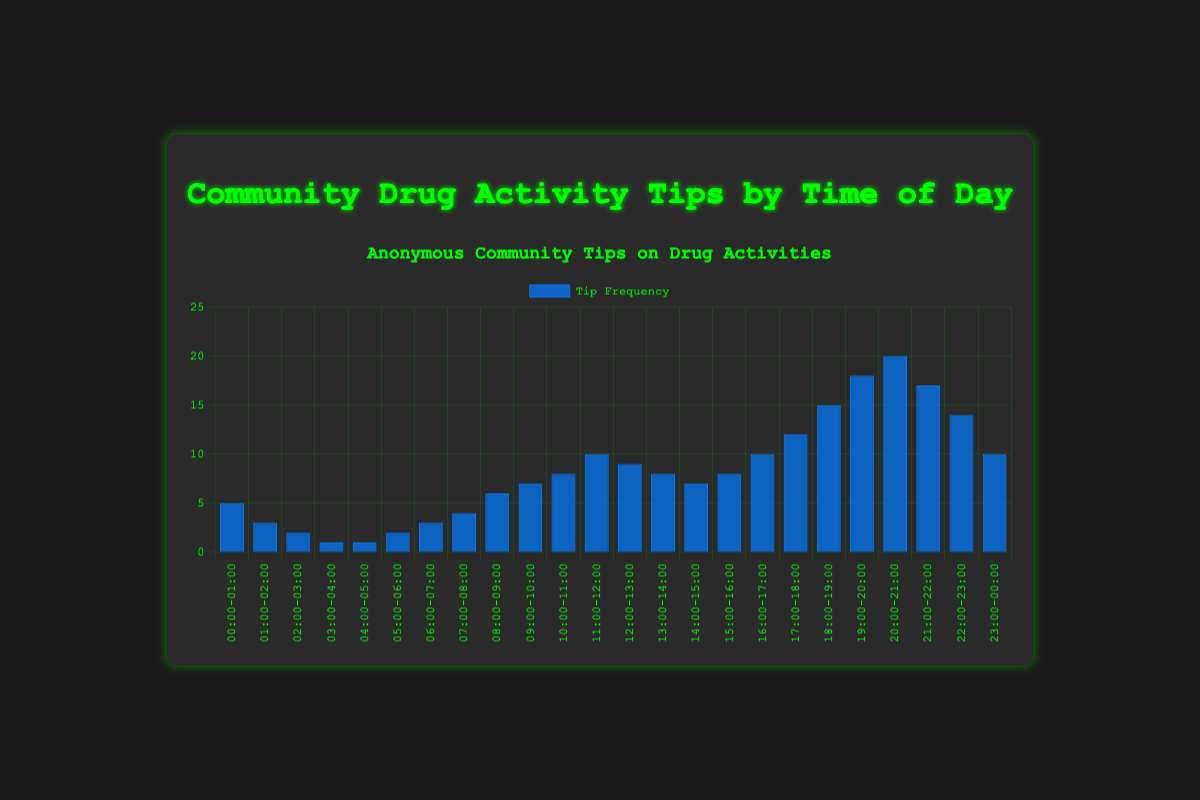What is the peak hour for community tips about drug activities? The highest bar in the chart represents the period from 20:00 to 21:00, indicating that this hour has the highest frequency of tips.
Answer: 20:00-21:00 Which period has the lowest frequency of tips? The shortest bars on the chart represent the periods 03:00-04:00 and 04:00-05:00, each with a frequency of 1 tip.
Answer: 03:00-04:00 and 04:00-05:00 How many tips are reported between 18:00 and 21:00? The periods between 18:00-21:00 have frequencies of 15, 18, and 20. Adding these together: 15 + 18 + 20 = 53.
Answer: 53 Compare the frequency of tips between 16:00-17:00 and 22:00-23:00. Which is higher? The bar for 16:00-17:00 has a frequency of 10 tips, while the bar for 22:00-23:00 has a frequency of 14 tips. 14 is greater than 10.
Answer: 22:00-23:00 What is the average frequency of tips between 12:00 and 18:00? The periods between 12:00 and 18:00 have frequencies of 9, 8, 7, 8, 10, and 12. Adding these together: 9 + 8 + 7 + 8 + 10 + 12 = 54. The average is 54 / 6 = 9.
Answer: 9 During which period does the frequency increase the most compared to the previous period? The biggest increase is between 19:00-20:00 and 20:00-21:00, where the frequency jumps from 18 to 20 (an increase of 2).
Answer: 19:00-20:00 to 20:00-21:00 How many periods have a tip frequency greater than 15? The chart shows three periods with frequencies greater than 15: 20:00-21:00, 21:00-22:00, and 19:00-20:00.
Answer: 3 Is the number of tips higher between 09:00 and 12:00 or between 14:00 and 17:00? The periods 09:00-12:00 have frequencies of 7, 8, and 10. Their sum is 7 + 8 + 10 = 25. The periods between 14:00 and 17:00 have frequencies of 7, 8, and 10. Their sum is also 7 + 8 + 10 = 25.
Answer: Equal 